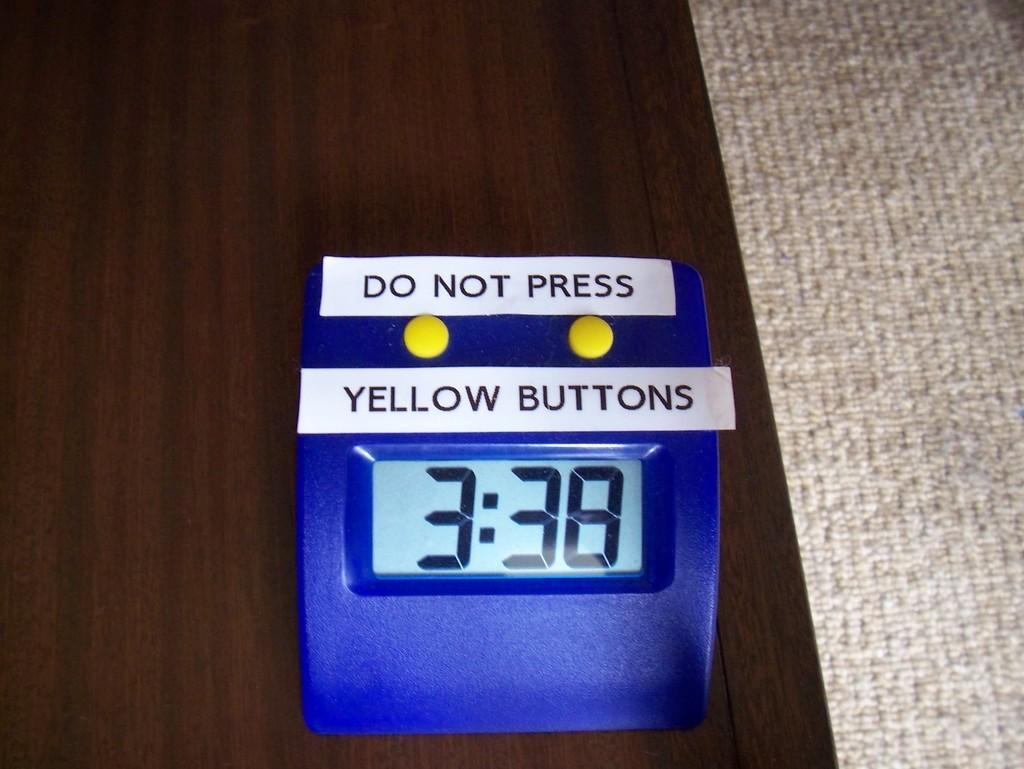<image>
Create a compact narrative representing the image presented. A blue digital clock has two pieces of paper attached to the top that read do not press yellow buttons. 